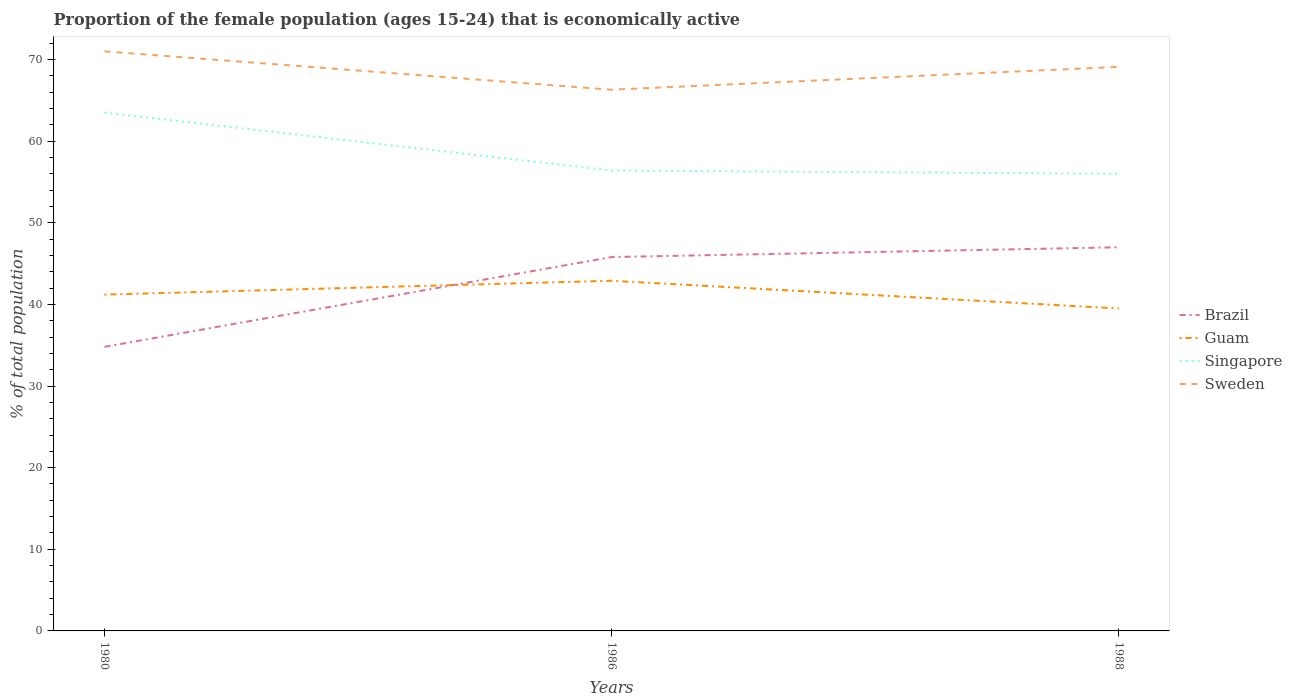How many different coloured lines are there?
Your answer should be compact. 4. Is the number of lines equal to the number of legend labels?
Keep it short and to the point. Yes. Across all years, what is the maximum proportion of the female population that is economically active in Sweden?
Your answer should be very brief. 66.3. In which year was the proportion of the female population that is economically active in Sweden maximum?
Give a very brief answer. 1986. What is the total proportion of the female population that is economically active in Guam in the graph?
Your response must be concise. -1.7. What is the difference between the highest and the second highest proportion of the female population that is economically active in Sweden?
Offer a terse response. 4.7. What is the difference between the highest and the lowest proportion of the female population that is economically active in Brazil?
Provide a succinct answer. 2. What is the difference between two consecutive major ticks on the Y-axis?
Make the answer very short. 10. How many legend labels are there?
Ensure brevity in your answer.  4. How are the legend labels stacked?
Offer a terse response. Vertical. What is the title of the graph?
Provide a short and direct response. Proportion of the female population (ages 15-24) that is economically active. What is the label or title of the X-axis?
Your answer should be compact. Years. What is the label or title of the Y-axis?
Your answer should be compact. % of total population. What is the % of total population in Brazil in 1980?
Offer a very short reply. 34.8. What is the % of total population in Guam in 1980?
Provide a succinct answer. 41.2. What is the % of total population of Singapore in 1980?
Keep it short and to the point. 63.5. What is the % of total population in Sweden in 1980?
Offer a very short reply. 71. What is the % of total population of Brazil in 1986?
Your response must be concise. 45.8. What is the % of total population in Guam in 1986?
Provide a short and direct response. 42.9. What is the % of total population of Singapore in 1986?
Offer a very short reply. 56.4. What is the % of total population in Sweden in 1986?
Offer a terse response. 66.3. What is the % of total population of Guam in 1988?
Offer a very short reply. 39.5. What is the % of total population of Singapore in 1988?
Provide a short and direct response. 56. What is the % of total population in Sweden in 1988?
Your response must be concise. 69.1. Across all years, what is the maximum % of total population in Guam?
Provide a succinct answer. 42.9. Across all years, what is the maximum % of total population of Singapore?
Offer a terse response. 63.5. Across all years, what is the minimum % of total population of Brazil?
Your answer should be very brief. 34.8. Across all years, what is the minimum % of total population of Guam?
Make the answer very short. 39.5. Across all years, what is the minimum % of total population in Sweden?
Make the answer very short. 66.3. What is the total % of total population in Brazil in the graph?
Offer a very short reply. 127.6. What is the total % of total population of Guam in the graph?
Ensure brevity in your answer.  123.6. What is the total % of total population of Singapore in the graph?
Offer a very short reply. 175.9. What is the total % of total population of Sweden in the graph?
Your response must be concise. 206.4. What is the difference between the % of total population in Guam in 1980 and that in 1986?
Your answer should be compact. -1.7. What is the difference between the % of total population of Brazil in 1980 and that in 1988?
Your response must be concise. -12.2. What is the difference between the % of total population in Singapore in 1980 and that in 1988?
Your answer should be very brief. 7.5. What is the difference between the % of total population in Brazil in 1986 and that in 1988?
Keep it short and to the point. -1.2. What is the difference between the % of total population of Guam in 1986 and that in 1988?
Your answer should be compact. 3.4. What is the difference between the % of total population of Singapore in 1986 and that in 1988?
Provide a succinct answer. 0.4. What is the difference between the % of total population of Sweden in 1986 and that in 1988?
Your response must be concise. -2.8. What is the difference between the % of total population in Brazil in 1980 and the % of total population in Guam in 1986?
Your answer should be compact. -8.1. What is the difference between the % of total population of Brazil in 1980 and the % of total population of Singapore in 1986?
Make the answer very short. -21.6. What is the difference between the % of total population in Brazil in 1980 and the % of total population in Sweden in 1986?
Make the answer very short. -31.5. What is the difference between the % of total population in Guam in 1980 and the % of total population in Singapore in 1986?
Offer a very short reply. -15.2. What is the difference between the % of total population in Guam in 1980 and the % of total population in Sweden in 1986?
Make the answer very short. -25.1. What is the difference between the % of total population of Singapore in 1980 and the % of total population of Sweden in 1986?
Provide a short and direct response. -2.8. What is the difference between the % of total population in Brazil in 1980 and the % of total population in Guam in 1988?
Your answer should be very brief. -4.7. What is the difference between the % of total population in Brazil in 1980 and the % of total population in Singapore in 1988?
Provide a short and direct response. -21.2. What is the difference between the % of total population of Brazil in 1980 and the % of total population of Sweden in 1988?
Make the answer very short. -34.3. What is the difference between the % of total population in Guam in 1980 and the % of total population in Singapore in 1988?
Keep it short and to the point. -14.8. What is the difference between the % of total population of Guam in 1980 and the % of total population of Sweden in 1988?
Make the answer very short. -27.9. What is the difference between the % of total population in Brazil in 1986 and the % of total population in Singapore in 1988?
Provide a short and direct response. -10.2. What is the difference between the % of total population in Brazil in 1986 and the % of total population in Sweden in 1988?
Provide a short and direct response. -23.3. What is the difference between the % of total population of Guam in 1986 and the % of total population of Sweden in 1988?
Provide a succinct answer. -26.2. What is the difference between the % of total population in Singapore in 1986 and the % of total population in Sweden in 1988?
Offer a terse response. -12.7. What is the average % of total population in Brazil per year?
Make the answer very short. 42.53. What is the average % of total population in Guam per year?
Your answer should be very brief. 41.2. What is the average % of total population in Singapore per year?
Ensure brevity in your answer.  58.63. What is the average % of total population of Sweden per year?
Provide a succinct answer. 68.8. In the year 1980, what is the difference between the % of total population of Brazil and % of total population of Singapore?
Offer a terse response. -28.7. In the year 1980, what is the difference between the % of total population in Brazil and % of total population in Sweden?
Keep it short and to the point. -36.2. In the year 1980, what is the difference between the % of total population of Guam and % of total population of Singapore?
Give a very brief answer. -22.3. In the year 1980, what is the difference between the % of total population of Guam and % of total population of Sweden?
Your answer should be very brief. -29.8. In the year 1980, what is the difference between the % of total population of Singapore and % of total population of Sweden?
Keep it short and to the point. -7.5. In the year 1986, what is the difference between the % of total population in Brazil and % of total population in Singapore?
Your answer should be very brief. -10.6. In the year 1986, what is the difference between the % of total population in Brazil and % of total population in Sweden?
Offer a very short reply. -20.5. In the year 1986, what is the difference between the % of total population in Guam and % of total population in Singapore?
Make the answer very short. -13.5. In the year 1986, what is the difference between the % of total population of Guam and % of total population of Sweden?
Offer a terse response. -23.4. In the year 1986, what is the difference between the % of total population of Singapore and % of total population of Sweden?
Your response must be concise. -9.9. In the year 1988, what is the difference between the % of total population of Brazil and % of total population of Singapore?
Offer a very short reply. -9. In the year 1988, what is the difference between the % of total population in Brazil and % of total population in Sweden?
Give a very brief answer. -22.1. In the year 1988, what is the difference between the % of total population of Guam and % of total population of Singapore?
Your response must be concise. -16.5. In the year 1988, what is the difference between the % of total population in Guam and % of total population in Sweden?
Your answer should be compact. -29.6. In the year 1988, what is the difference between the % of total population of Singapore and % of total population of Sweden?
Make the answer very short. -13.1. What is the ratio of the % of total population of Brazil in 1980 to that in 1986?
Offer a very short reply. 0.76. What is the ratio of the % of total population in Guam in 1980 to that in 1986?
Your answer should be very brief. 0.96. What is the ratio of the % of total population of Singapore in 1980 to that in 1986?
Keep it short and to the point. 1.13. What is the ratio of the % of total population in Sweden in 1980 to that in 1986?
Your response must be concise. 1.07. What is the ratio of the % of total population in Brazil in 1980 to that in 1988?
Keep it short and to the point. 0.74. What is the ratio of the % of total population in Guam in 1980 to that in 1988?
Offer a terse response. 1.04. What is the ratio of the % of total population in Singapore in 1980 to that in 1988?
Provide a short and direct response. 1.13. What is the ratio of the % of total population of Sweden in 1980 to that in 1988?
Ensure brevity in your answer.  1.03. What is the ratio of the % of total population in Brazil in 1986 to that in 1988?
Your response must be concise. 0.97. What is the ratio of the % of total population of Guam in 1986 to that in 1988?
Provide a short and direct response. 1.09. What is the ratio of the % of total population of Singapore in 1986 to that in 1988?
Your answer should be compact. 1.01. What is the ratio of the % of total population in Sweden in 1986 to that in 1988?
Provide a succinct answer. 0.96. What is the difference between the highest and the second highest % of total population of Sweden?
Your answer should be compact. 1.9. What is the difference between the highest and the lowest % of total population in Brazil?
Make the answer very short. 12.2. What is the difference between the highest and the lowest % of total population in Singapore?
Provide a succinct answer. 7.5. What is the difference between the highest and the lowest % of total population of Sweden?
Offer a terse response. 4.7. 